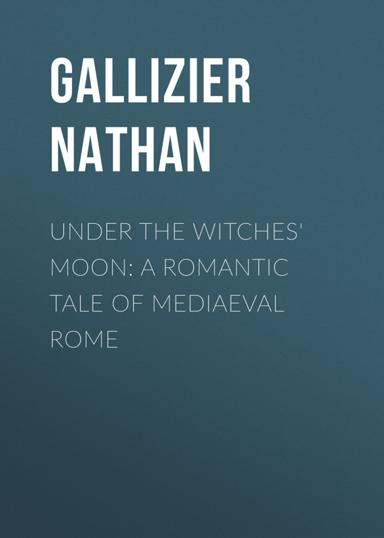How does the atmosphere of medieval Rome contribute to the narrative of the book? The atmospheric and gritty setting of medieval Rome significantly enhances the narrative of "Under the Witches' Moon." The cobblestone streets, the looming architecture, and the pervasive sense of mystery and danger inherent to this era, all serve to heighten the mystical and romantic elements of the story, making it not only a tale of personal connections but also a vivid portrait of a city in one of its most transformative periods. 